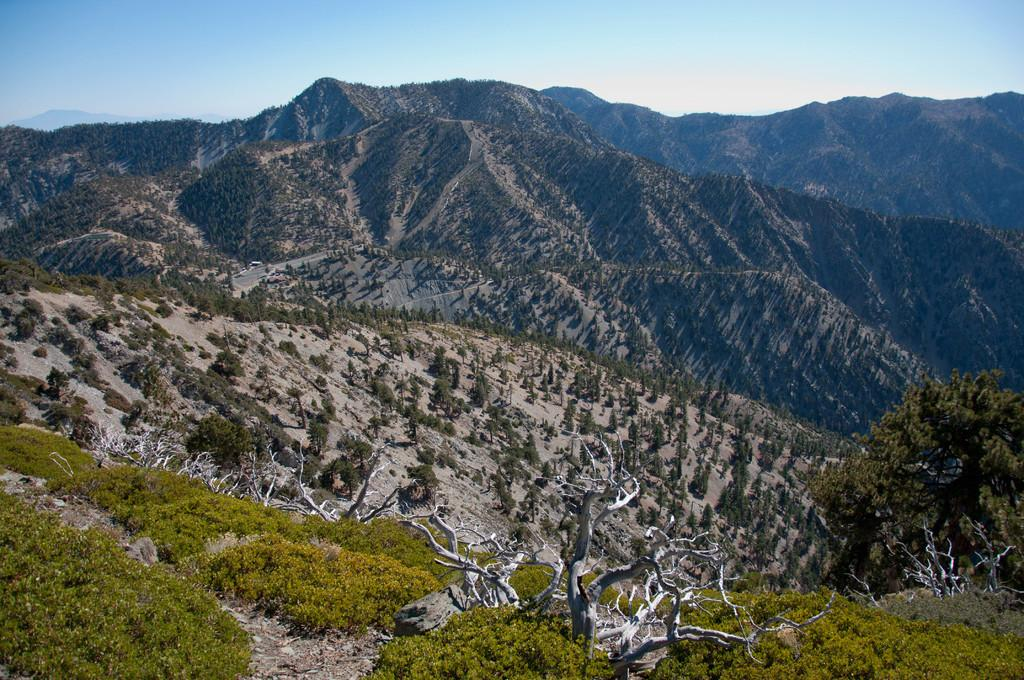What type of natural landscape is depicted in the image? The image features mountains. What type of vegetation can be seen in the image? There is grass and plants visible in the image. What part of the natural environment is visible in the image? The sky is visible in the image. What type of pear is being held by the partner in the image? There is no partner or pear present in the image. 